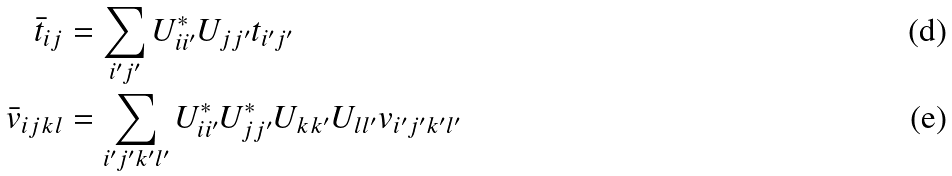Convert formula to latex. <formula><loc_0><loc_0><loc_500><loc_500>\bar { t } _ { i j } & = \sum _ { i ^ { \prime } j ^ { \prime } } U _ { i i ^ { \prime } } ^ { * } U _ { j j ^ { \prime } } { t } _ { i ^ { \prime } j ^ { \prime } } \\ \bar { v } _ { i j k l } & = \sum _ { i ^ { \prime } j ^ { \prime } k ^ { \prime } l ^ { \prime } } U _ { i i ^ { \prime } } ^ { * } U _ { j j ^ { \prime } } ^ { * } U _ { k k ^ { \prime } } U _ { l l ^ { \prime } } { v } _ { i ^ { \prime } j ^ { \prime } k ^ { \prime } l ^ { \prime } }</formula> 